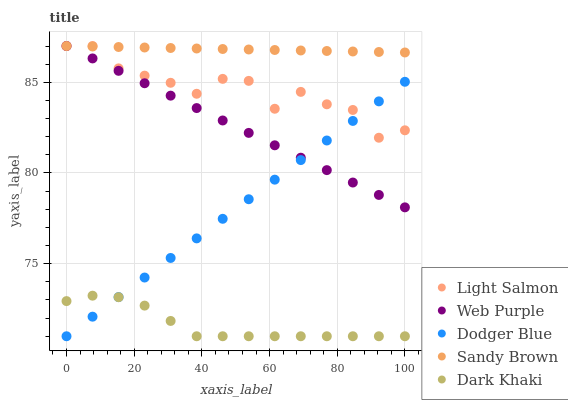Does Dark Khaki have the minimum area under the curve?
Answer yes or no. Yes. Does Sandy Brown have the maximum area under the curve?
Answer yes or no. Yes. Does Light Salmon have the minimum area under the curve?
Answer yes or no. No. Does Light Salmon have the maximum area under the curve?
Answer yes or no. No. Is Web Purple the smoothest?
Answer yes or no. Yes. Is Light Salmon the roughest?
Answer yes or no. Yes. Is Sandy Brown the smoothest?
Answer yes or no. No. Is Sandy Brown the roughest?
Answer yes or no. No. Does Dark Khaki have the lowest value?
Answer yes or no. Yes. Does Light Salmon have the lowest value?
Answer yes or no. No. Does Web Purple have the highest value?
Answer yes or no. Yes. Does Dodger Blue have the highest value?
Answer yes or no. No. Is Dark Khaki less than Web Purple?
Answer yes or no. Yes. Is Sandy Brown greater than Dark Khaki?
Answer yes or no. Yes. Does Web Purple intersect Dodger Blue?
Answer yes or no. Yes. Is Web Purple less than Dodger Blue?
Answer yes or no. No. Is Web Purple greater than Dodger Blue?
Answer yes or no. No. Does Dark Khaki intersect Web Purple?
Answer yes or no. No. 